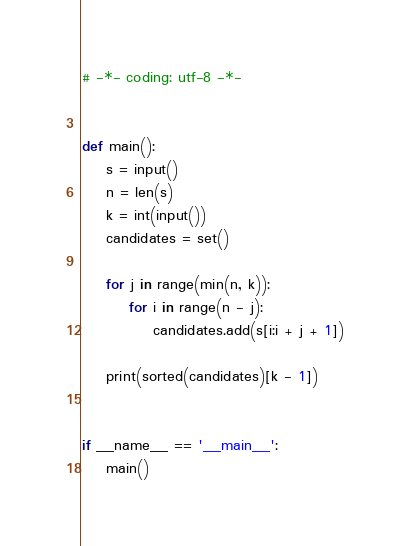Convert code to text. <code><loc_0><loc_0><loc_500><loc_500><_Python_># -*- coding: utf-8 -*-


def main():
    s = input()
    n = len(s)
    k = int(input())
    candidates = set()

    for j in range(min(n, k)):
        for i in range(n - j):
            candidates.add(s[i:i + j + 1])

    print(sorted(candidates)[k - 1])


if __name__ == '__main__':
    main()
</code> 